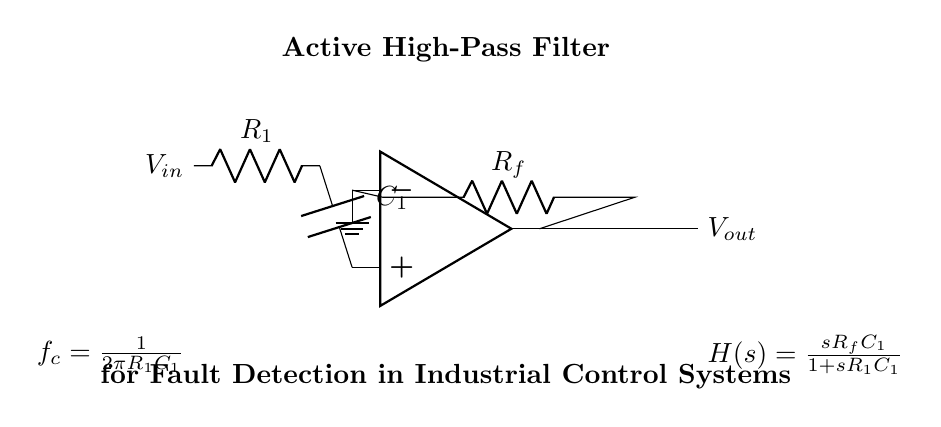What type of filter is represented in this circuit? The diagram indicates an active high-pass filter, as shown by the title in the circuit and its configuration with capacitors and resistors specifically designed to allow high-frequency signals while attenuating low-frequency ones.
Answer: Active high-pass filter What components are used in this filter circuit? The circuit includes an operational amplifier, a resistor labeled R1, another resistor labeled Rf, and a capacitor labeled C1, all of which are crucial for creating the active high-pass filter functionality.
Answer: Operational amplifier, R1, Rf, C1 What is the transfer function of this circuit? The transfer function is displayed in the diagram as H(s) = sR_fC_1/(1 + sR_1C_1). This ratio of the Laplace variable s multiplied by the feedback resistor and capacitor to the sum of one and the product of the input resistor and capacitor reflects the circuit's behavior.
Answer: sR_fC_1/(1 + sR_1C_1) What is the cutoff frequency formula provided in the circuit? The cutoff frequency f_c is defined in the circuit as f_c = 1/(2πR1C1). This formula allows one to calculate the frequency at which the filter begins to pass signals with less attenuation.
Answer: 1/(2πR1C1) How does the feedback resistor influence the gain of the circuit? The feedback resistor Rf is critical as it determines the gain of the active filter. The gain can be derived from the relationship of the resistors in the feedback loop and influences the filtering characteristics, particularly in how well the circuit can amplify high-frequency inputs relative to low-frequency noise.
Answer: It determines the gain At what point is the ground connected in the circuit? The ground connection is made at the inverting input of the operational amplifier, which is a common grounding point in op-amp circuits and stabilizes the reference point for the voltages in the system.
Answer: Inverting input of the op-amp 